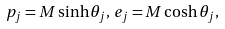<formula> <loc_0><loc_0><loc_500><loc_500>p _ { j } = M \sinh \theta _ { j } , \, e _ { j } = M \cosh \theta _ { j } ,</formula> 